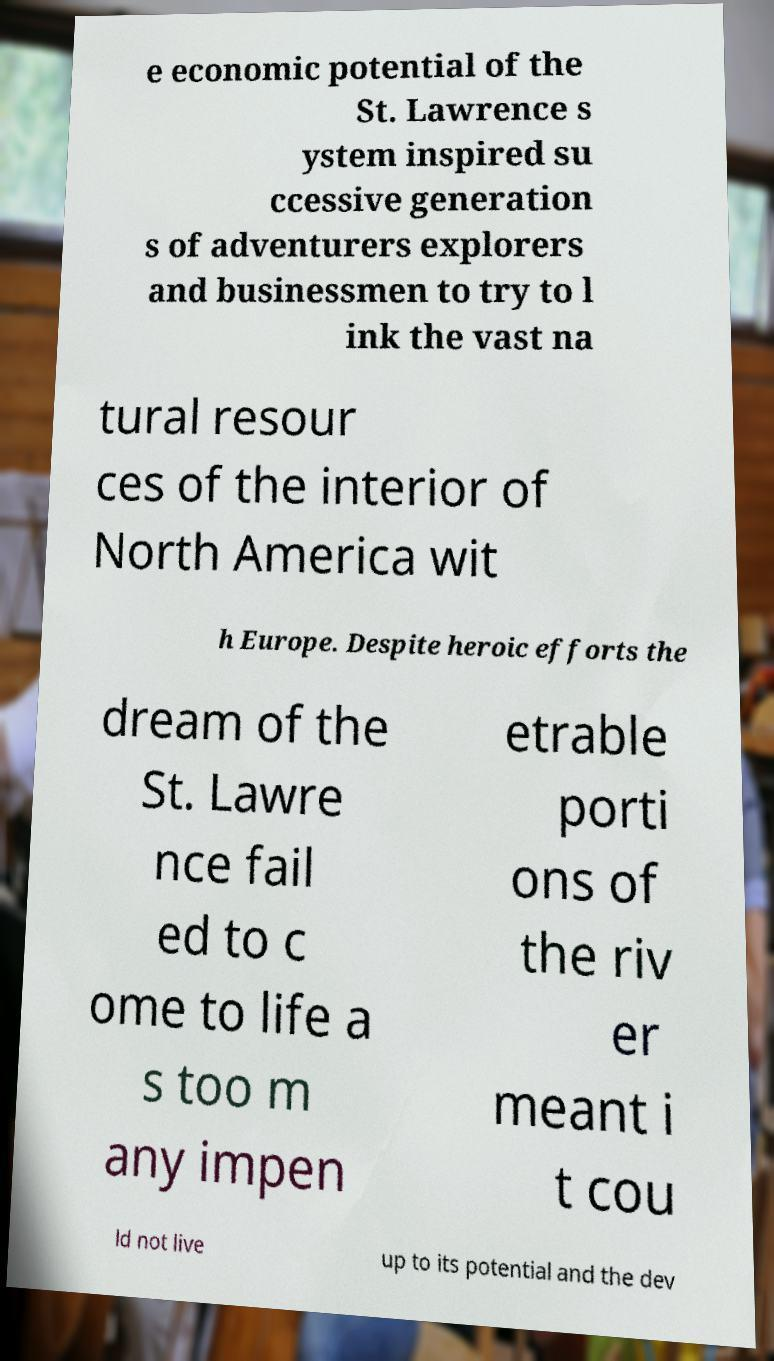Can you read and provide the text displayed in the image?This photo seems to have some interesting text. Can you extract and type it out for me? e economic potential of the St. Lawrence s ystem inspired su ccessive generation s of adventurers explorers and businessmen to try to l ink the vast na tural resour ces of the interior of North America wit h Europe. Despite heroic efforts the dream of the St. Lawre nce fail ed to c ome to life a s too m any impen etrable porti ons of the riv er meant i t cou ld not live up to its potential and the dev 